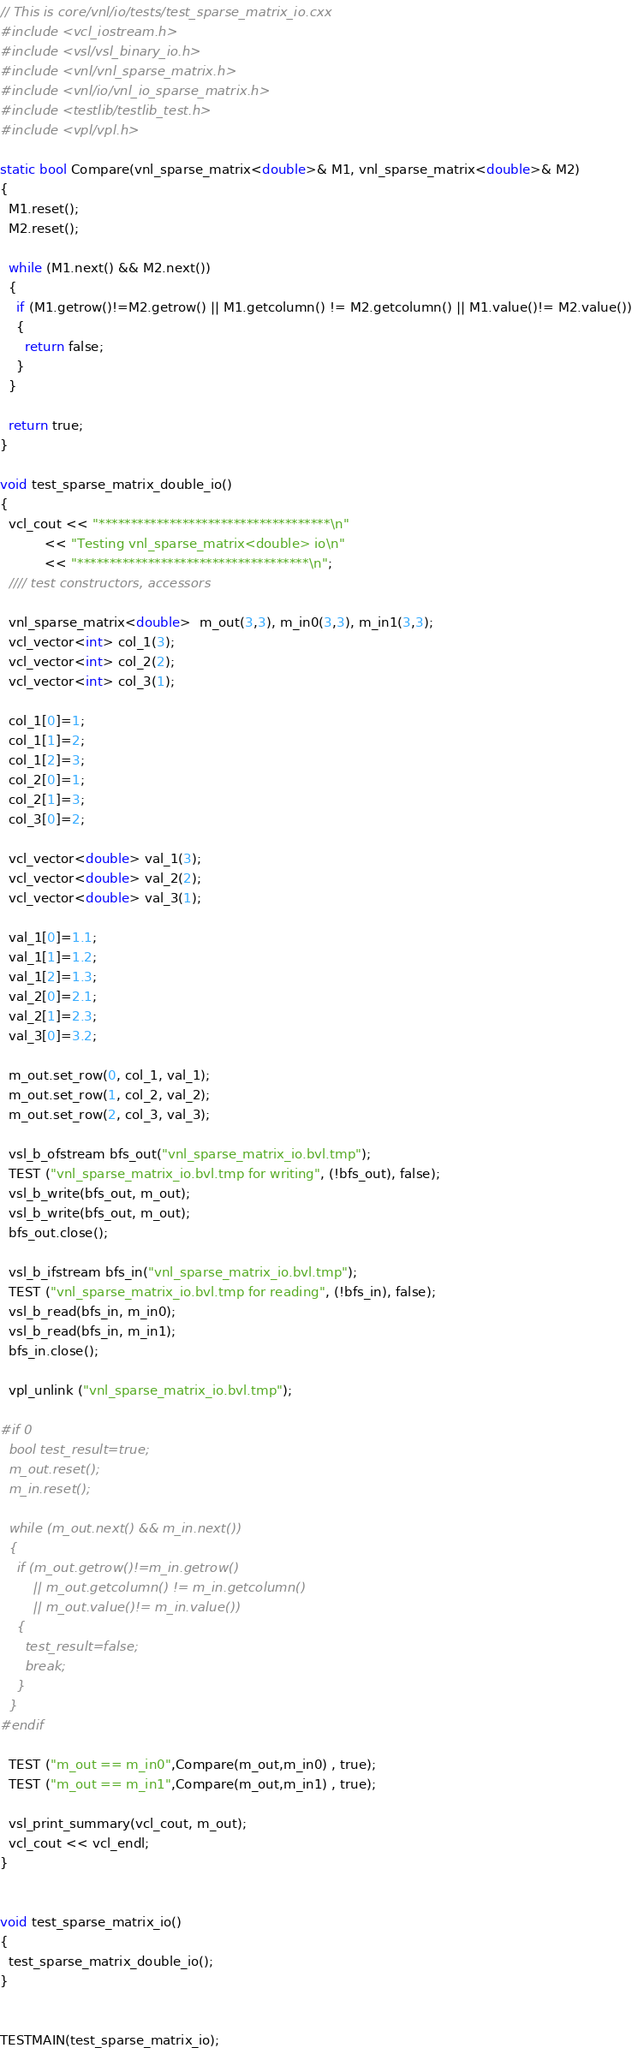<code> <loc_0><loc_0><loc_500><loc_500><_C++_>// This is core/vnl/io/tests/test_sparse_matrix_io.cxx
#include <vcl_iostream.h>
#include <vsl/vsl_binary_io.h>
#include <vnl/vnl_sparse_matrix.h>
#include <vnl/io/vnl_io_sparse_matrix.h>
#include <testlib/testlib_test.h>
#include <vpl/vpl.h>

static bool Compare(vnl_sparse_matrix<double>& M1, vnl_sparse_matrix<double>& M2)
{
  M1.reset();
  M2.reset();

  while (M1.next() && M2.next())
  {
    if (M1.getrow()!=M2.getrow() || M1.getcolumn() != M2.getcolumn() || M1.value()!= M2.value())
    {
      return false;
    }
  }

  return true;
}

void test_sparse_matrix_double_io()
{
  vcl_cout << "************************************\n"
           << "Testing vnl_sparse_matrix<double> io\n"
           << "************************************\n";
  //// test constructors, accessors

  vnl_sparse_matrix<double>  m_out(3,3), m_in0(3,3), m_in1(3,3);
  vcl_vector<int> col_1(3);
  vcl_vector<int> col_2(2);
  vcl_vector<int> col_3(1);

  col_1[0]=1;
  col_1[1]=2;
  col_1[2]=3;
  col_2[0]=1;
  col_2[1]=3;
  col_3[0]=2;

  vcl_vector<double> val_1(3);
  vcl_vector<double> val_2(2);
  vcl_vector<double> val_3(1);

  val_1[0]=1.1;
  val_1[1]=1.2;
  val_1[2]=1.3;
  val_2[0]=2.1;
  val_2[1]=2.3;
  val_3[0]=3.2;

  m_out.set_row(0, col_1, val_1);
  m_out.set_row(1, col_2, val_2);
  m_out.set_row(2, col_3, val_3);

  vsl_b_ofstream bfs_out("vnl_sparse_matrix_io.bvl.tmp");
  TEST ("vnl_sparse_matrix_io.bvl.tmp for writing", (!bfs_out), false);
  vsl_b_write(bfs_out, m_out);
  vsl_b_write(bfs_out, m_out);
  bfs_out.close();

  vsl_b_ifstream bfs_in("vnl_sparse_matrix_io.bvl.tmp");
  TEST ("vnl_sparse_matrix_io.bvl.tmp for reading", (!bfs_in), false);
  vsl_b_read(bfs_in, m_in0);
  vsl_b_read(bfs_in, m_in1);
  bfs_in.close();

  vpl_unlink ("vnl_sparse_matrix_io.bvl.tmp");

#if 0
  bool test_result=true;
  m_out.reset();
  m_in.reset();

  while (m_out.next() && m_in.next())
  {
    if (m_out.getrow()!=m_in.getrow()
        || m_out.getcolumn() != m_in.getcolumn()
        || m_out.value()!= m_in.value())
    {
      test_result=false;
      break;
    }
  }
#endif

  TEST ("m_out == m_in0",Compare(m_out,m_in0) , true);
  TEST ("m_out == m_in1",Compare(m_out,m_in1) , true);

  vsl_print_summary(vcl_cout, m_out);
  vcl_cout << vcl_endl;
}


void test_sparse_matrix_io()
{
  test_sparse_matrix_double_io();
}


TESTMAIN(test_sparse_matrix_io);
</code> 